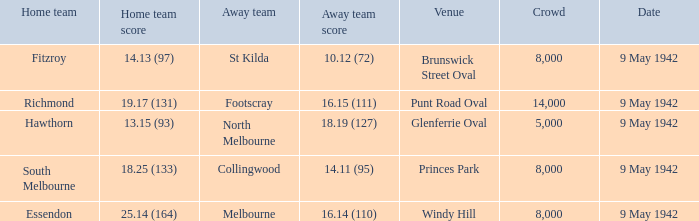Would you be able to parse every entry in this table? {'header': ['Home team', 'Home team score', 'Away team', 'Away team score', 'Venue', 'Crowd', 'Date'], 'rows': [['Fitzroy', '14.13 (97)', 'St Kilda', '10.12 (72)', 'Brunswick Street Oval', '8,000', '9 May 1942'], ['Richmond', '19.17 (131)', 'Footscray', '16.15 (111)', 'Punt Road Oval', '14,000', '9 May 1942'], ['Hawthorn', '13.15 (93)', 'North Melbourne', '18.19 (127)', 'Glenferrie Oval', '5,000', '9 May 1942'], ['South Melbourne', '18.25 (133)', 'Collingwood', '14.11 (95)', 'Princes Park', '8,000', '9 May 1942'], ['Essendon', '25.14 (164)', 'Melbourne', '16.14 (110)', 'Windy Hill', '8,000', '9 May 1942']]} How many people attended the game with the home team scoring 18.25 (133)? 1.0. 